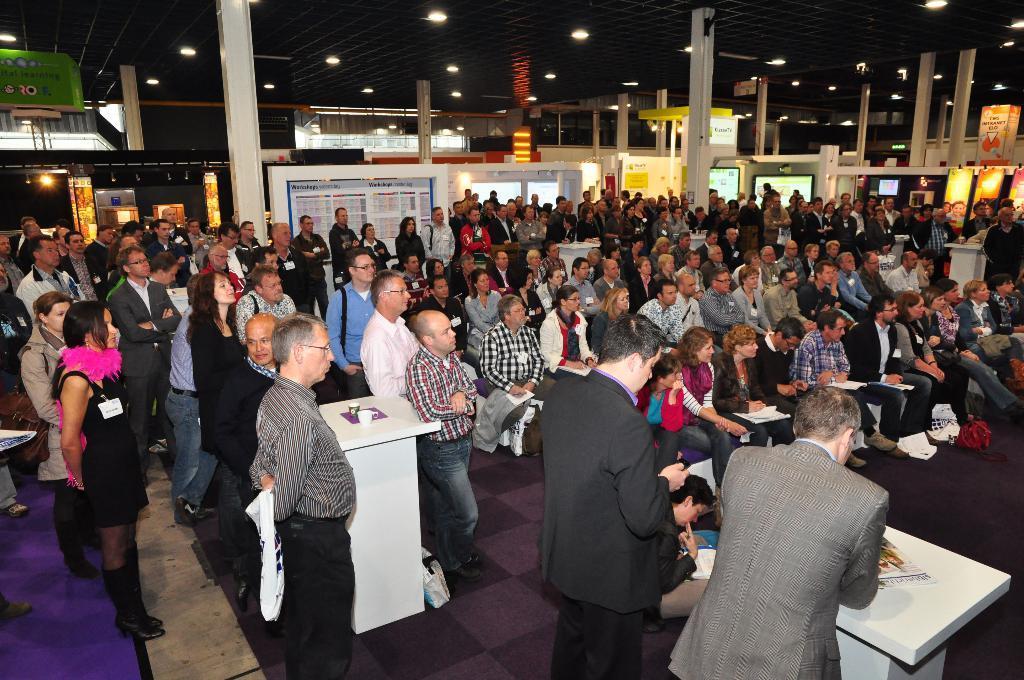In one or two sentences, can you explain what this image depicts? In this image there are a group of people some of them are sitting and some of them are standing, and also there are some podiums. On the podium there are some papers and cups and also in the background there are some pillars, lights, glass doors and some other objects. At the bottom there is a floor and on the floor there is a carpet, at the top of the image there is ceiling and some lights. 